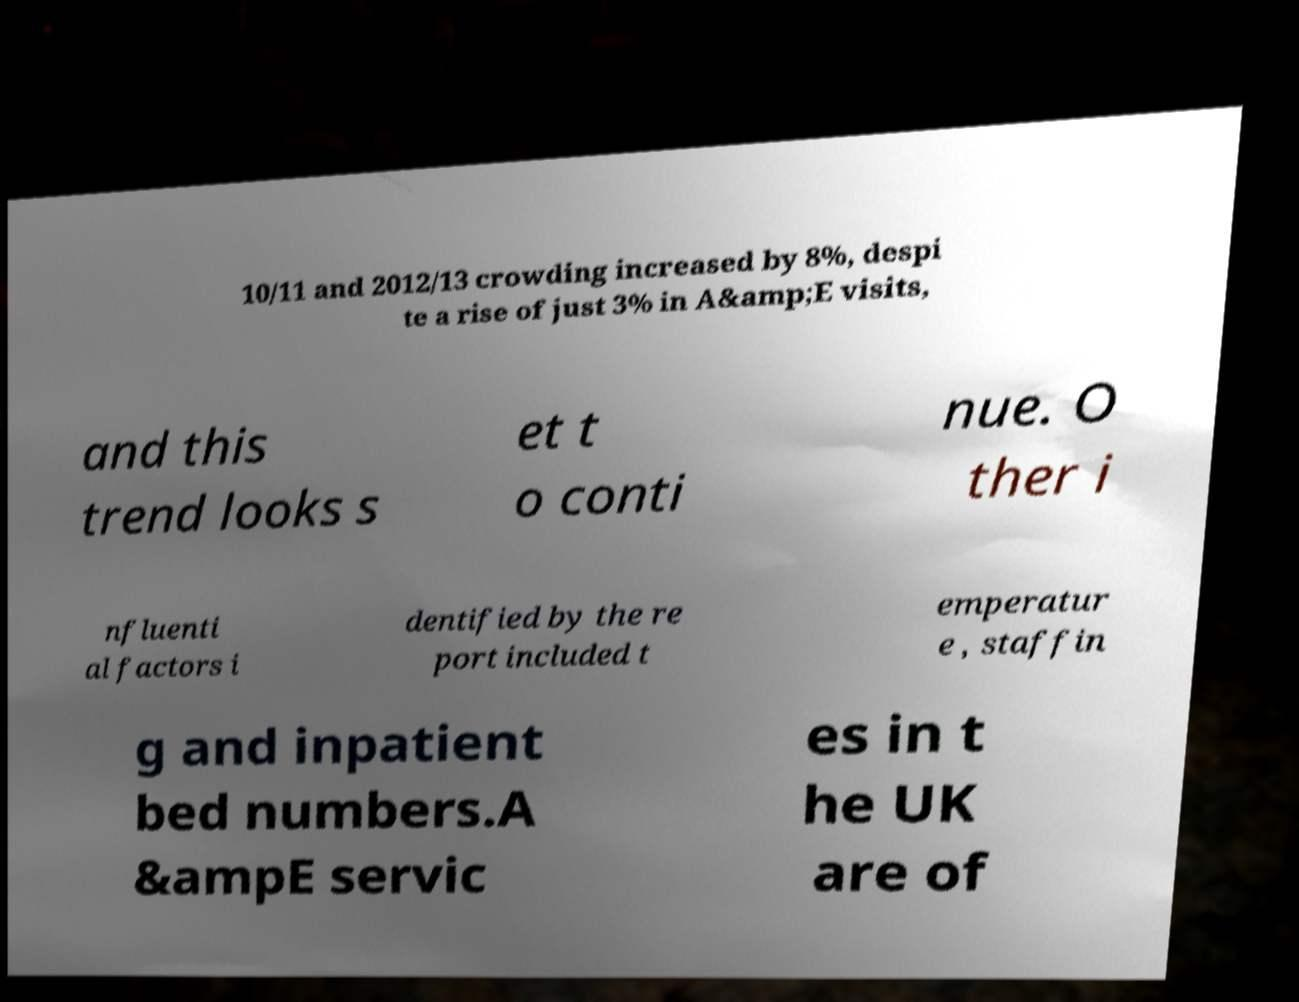Please identify and transcribe the text found in this image. 10/11 and 2012/13 crowding increased by 8%, despi te a rise of just 3% in A&amp;E visits, and this trend looks s et t o conti nue. O ther i nfluenti al factors i dentified by the re port included t emperatur e , staffin g and inpatient bed numbers.A &ampE servic es in t he UK are of 